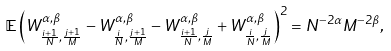<formula> <loc_0><loc_0><loc_500><loc_500>\mathbb { E } \left ( W ^ { \alpha , \beta } _ { \frac { i + 1 } { N } , \frac { j + 1 } { M } } - W ^ { \alpha , \beta } _ { \frac { i } { N } , \frac { j + 1 } { M } } - W ^ { \alpha , \beta } _ { \frac { i + 1 } { N } , \frac { j } { M } } + W ^ { \alpha , \beta } _ { \frac { i } { N } , \frac { j } { M } } \right ) ^ { 2 } = N ^ { - 2 \alpha } M ^ { - 2 \beta } ,</formula> 